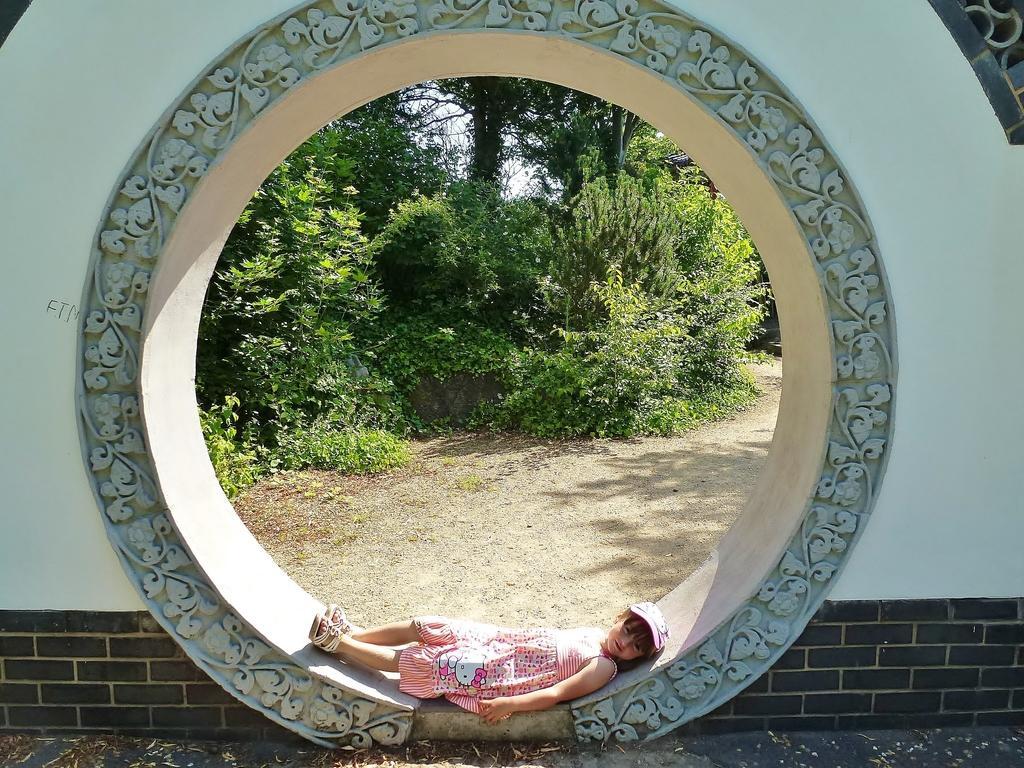Please provide a concise description of this image. In the foreground of this image, there is a girl in pink dress lying on a circular arch wall. In the background, there are trees and the ground. 